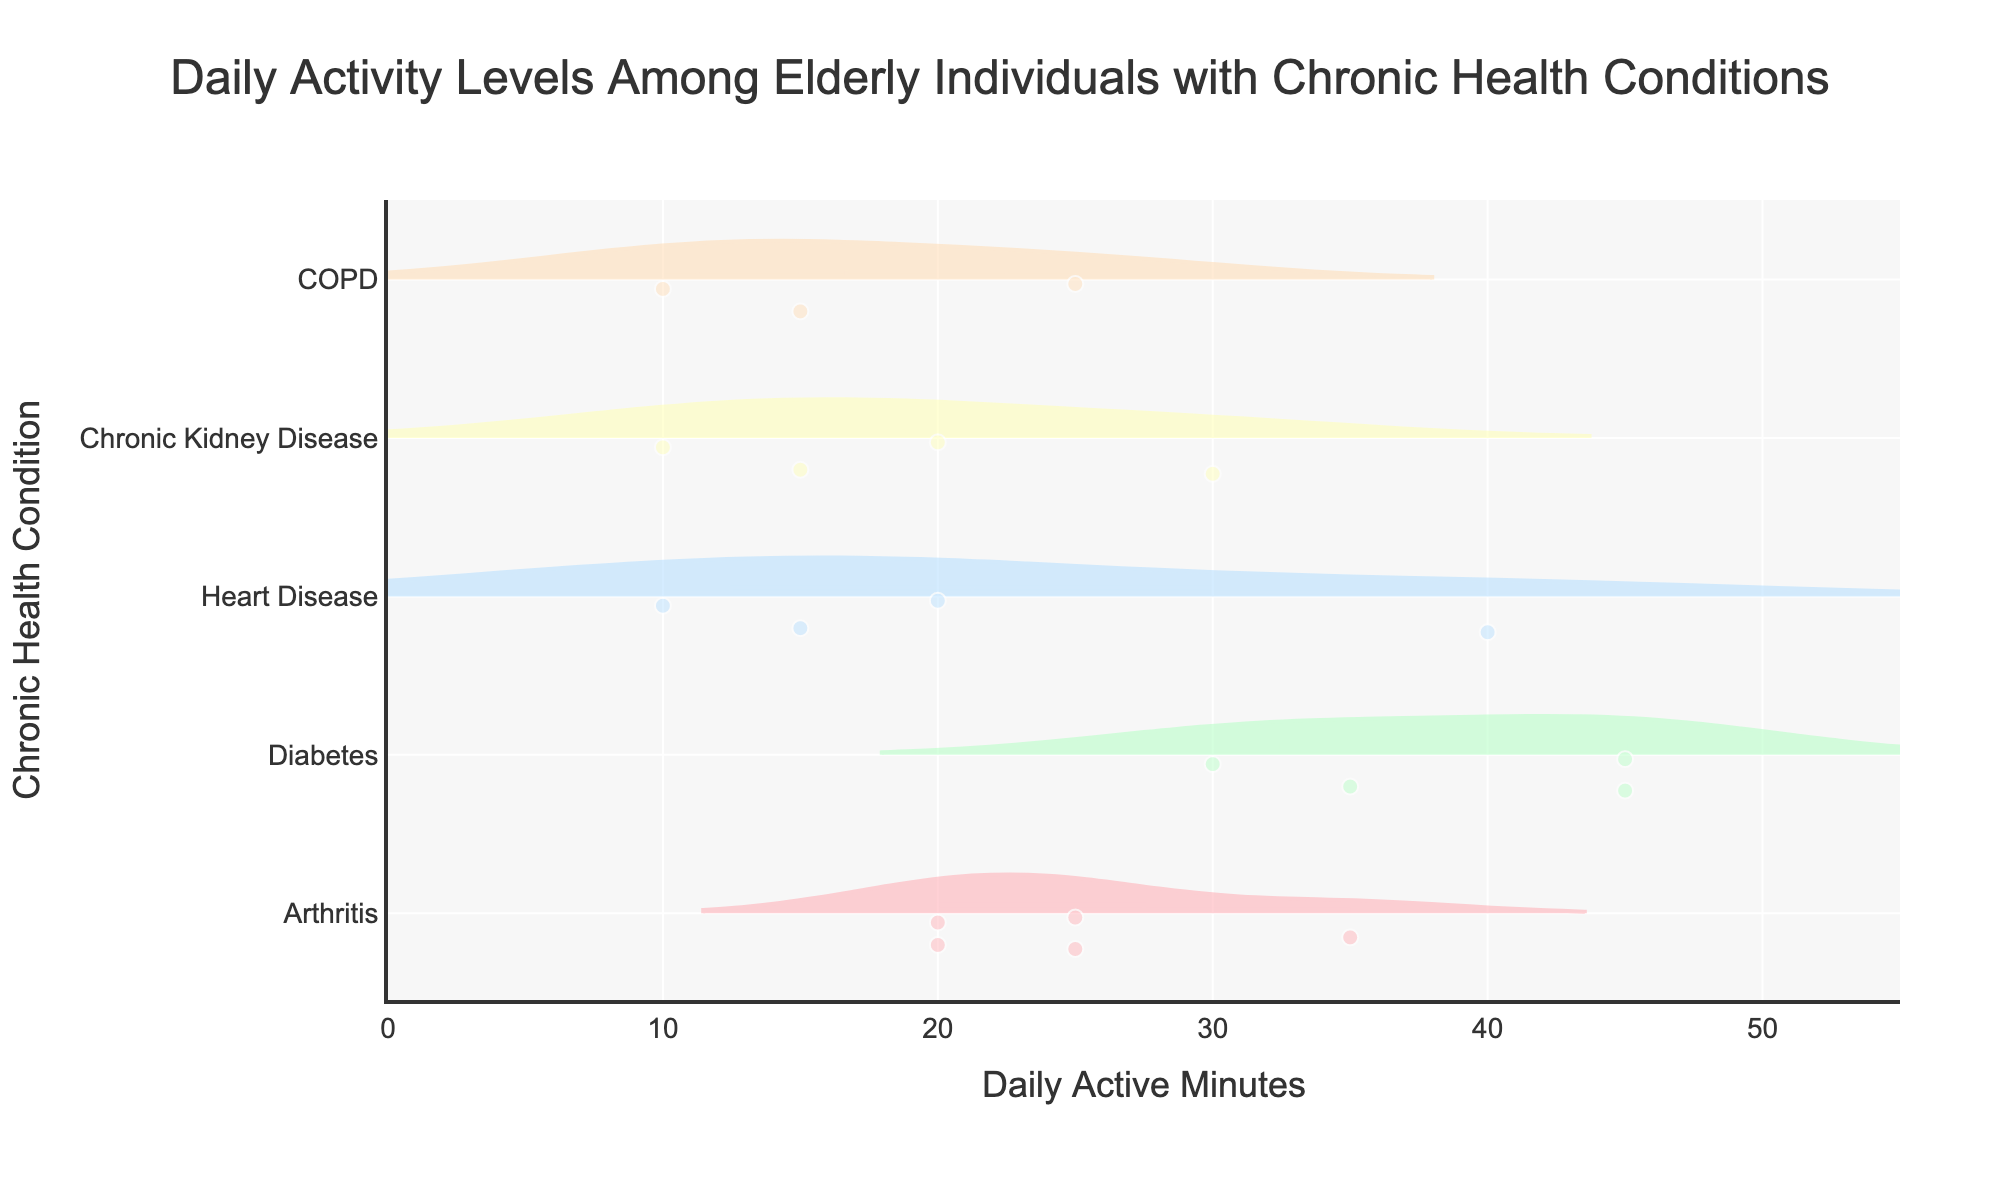What's the title of this figure? The title is usually placed prominently at the top of the figure. In this case, it is "Daily Activity Levels Among Elderly Individuals with Chronic Health Conditions," as mentioned in the layout description.
Answer: Daily Activity Levels Among Elderly Individuals with Chronic Health Conditions What does the x-axis represent? The label on the x-axis usually indicates what it represents. According to the code, the x-axis is labeled "Daily Active Minutes," showing the number of minutes each individual is active daily.
Answer: Daily Active Minutes Which chronic health condition shows the widest distribution of daily active minutes? By observing the width of the violin plots, the condition with the widest distribution can be identified. Diabetes has a wide distribution of daily active minutes, spreading across many values.
Answer: Diabetes Which condition has the lowest median daily active minutes? The median is usually displayed by a line within the violin plot. For the lowest median, COPD appears to have a lower median daily active minute value compared to others.
Answer: COPD How many different chronic health conditions are depicted in this figure? The number of unique chronic health conditions corresponds to the different violin plots. The code reveals there are five conditions: Arthritis, Diabetes, Heart Disease, Chronic Kidney Disease, and COPD.
Answer: 5 Which chronic health condition has the highest point for daily active minutes? The highest point in the violin plot indicates the maximum value recorded. The condition with the highest maximum value is Diabetes with a point at 45 minutes.
Answer: Diabetes Compare and contrast the daily active minutes for Chronic Kidney Disease and Heart Disease. The comparison involves looking at both median values and data distributions. Chronic Kidney Disease's distribution is generally lower with several values around 10-20 minutes, whereas Heart Disease has values but shows slightly higher medians and distributions around 10-40 minutes.
Answer: Heart Disease generally higher What is the range of daily active minutes for individuals with Arthritis? The range is seen by examining the farthest points of the violin plot for Arthritis from the lowest point to the highest. The range spans from as low as 20 to as high as 35 minutes.
Answer: 15 to 35 minutes Among the chronic health conditions, which one shows the least variance in daily active minutes? Variance is observed by the spread and concentration of data points in the violin plot. COPD demonstrates the least variance as most data points are concentrated around one value.
Answer: COPD Which chronic health condition has the most varied daily activity levels? The most variation is indicated by the spread and distribution breadth of the violin plot. Diabetes shows the most varied daily active minutes across the widest range.
Answer: Diabetes 